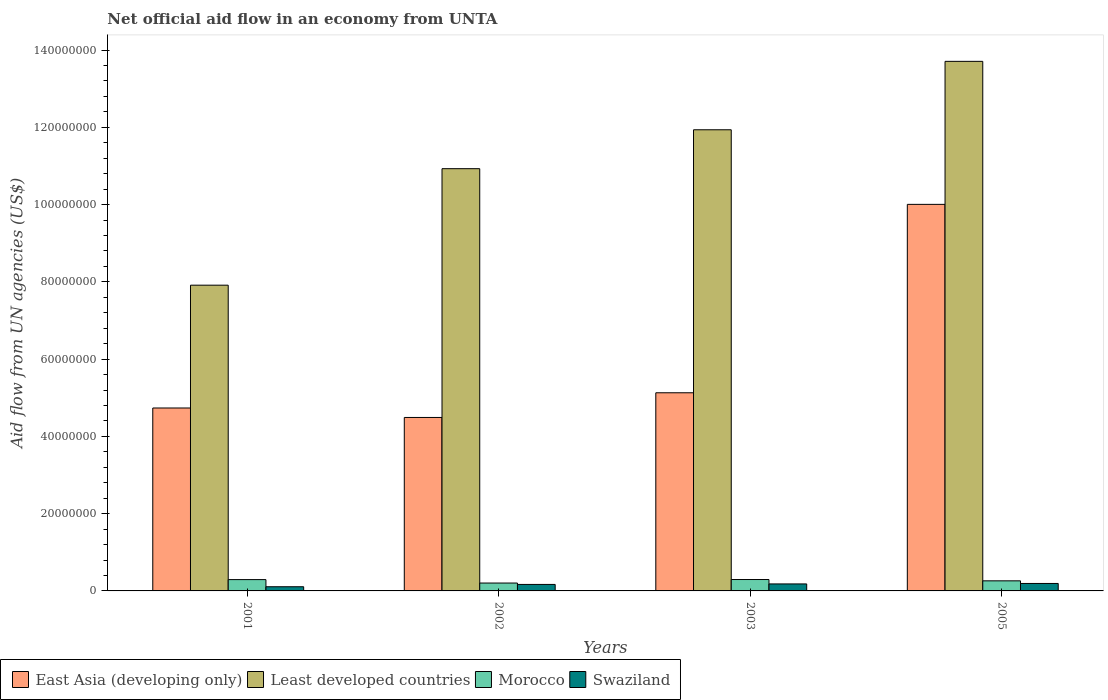How many different coloured bars are there?
Keep it short and to the point. 4. Are the number of bars per tick equal to the number of legend labels?
Give a very brief answer. Yes. Are the number of bars on each tick of the X-axis equal?
Your response must be concise. Yes. How many bars are there on the 1st tick from the right?
Offer a very short reply. 4. What is the label of the 3rd group of bars from the left?
Ensure brevity in your answer.  2003. What is the net official aid flow in Morocco in 2005?
Your answer should be compact. 2.61e+06. Across all years, what is the maximum net official aid flow in Least developed countries?
Offer a very short reply. 1.37e+08. Across all years, what is the minimum net official aid flow in Swaziland?
Make the answer very short. 1.08e+06. In which year was the net official aid flow in Morocco maximum?
Make the answer very short. 2003. What is the total net official aid flow in East Asia (developing only) in the graph?
Offer a very short reply. 2.44e+08. What is the difference between the net official aid flow in Morocco in 2003 and the net official aid flow in East Asia (developing only) in 2002?
Offer a very short reply. -4.20e+07. What is the average net official aid flow in East Asia (developing only) per year?
Your answer should be very brief. 6.09e+07. In the year 2001, what is the difference between the net official aid flow in Swaziland and net official aid flow in East Asia (developing only)?
Your response must be concise. -4.63e+07. In how many years, is the net official aid flow in Morocco greater than 76000000 US$?
Ensure brevity in your answer.  0. What is the ratio of the net official aid flow in Swaziland in 2001 to that in 2005?
Offer a very short reply. 0.56. Is the net official aid flow in Swaziland in 2002 less than that in 2005?
Your answer should be compact. Yes. Is the difference between the net official aid flow in Swaziland in 2003 and 2005 greater than the difference between the net official aid flow in East Asia (developing only) in 2003 and 2005?
Give a very brief answer. Yes. What is the difference between the highest and the second highest net official aid flow in East Asia (developing only)?
Make the answer very short. 4.88e+07. What is the difference between the highest and the lowest net official aid flow in Swaziland?
Keep it short and to the point. 8.50e+05. In how many years, is the net official aid flow in East Asia (developing only) greater than the average net official aid flow in East Asia (developing only) taken over all years?
Offer a very short reply. 1. Is the sum of the net official aid flow in Swaziland in 2001 and 2002 greater than the maximum net official aid flow in East Asia (developing only) across all years?
Give a very brief answer. No. Is it the case that in every year, the sum of the net official aid flow in Least developed countries and net official aid flow in Morocco is greater than the sum of net official aid flow in Swaziland and net official aid flow in East Asia (developing only)?
Provide a succinct answer. No. What does the 4th bar from the left in 2003 represents?
Provide a succinct answer. Swaziland. What does the 1st bar from the right in 2003 represents?
Provide a succinct answer. Swaziland. Is it the case that in every year, the sum of the net official aid flow in East Asia (developing only) and net official aid flow in Least developed countries is greater than the net official aid flow in Swaziland?
Keep it short and to the point. Yes. How many years are there in the graph?
Give a very brief answer. 4. What is the title of the graph?
Your answer should be very brief. Net official aid flow in an economy from UNTA. What is the label or title of the X-axis?
Offer a very short reply. Years. What is the label or title of the Y-axis?
Ensure brevity in your answer.  Aid flow from UN agencies (US$). What is the Aid flow from UN agencies (US$) in East Asia (developing only) in 2001?
Your answer should be very brief. 4.74e+07. What is the Aid flow from UN agencies (US$) in Least developed countries in 2001?
Ensure brevity in your answer.  7.91e+07. What is the Aid flow from UN agencies (US$) in Morocco in 2001?
Give a very brief answer. 2.93e+06. What is the Aid flow from UN agencies (US$) in Swaziland in 2001?
Your answer should be compact. 1.08e+06. What is the Aid flow from UN agencies (US$) of East Asia (developing only) in 2002?
Make the answer very short. 4.49e+07. What is the Aid flow from UN agencies (US$) of Least developed countries in 2002?
Your response must be concise. 1.09e+08. What is the Aid flow from UN agencies (US$) of Morocco in 2002?
Provide a short and direct response. 2.04e+06. What is the Aid flow from UN agencies (US$) in Swaziland in 2002?
Keep it short and to the point. 1.68e+06. What is the Aid flow from UN agencies (US$) in East Asia (developing only) in 2003?
Give a very brief answer. 5.13e+07. What is the Aid flow from UN agencies (US$) in Least developed countries in 2003?
Ensure brevity in your answer.  1.19e+08. What is the Aid flow from UN agencies (US$) of Morocco in 2003?
Your answer should be very brief. 2.95e+06. What is the Aid flow from UN agencies (US$) in Swaziland in 2003?
Your answer should be compact. 1.81e+06. What is the Aid flow from UN agencies (US$) in East Asia (developing only) in 2005?
Make the answer very short. 1.00e+08. What is the Aid flow from UN agencies (US$) of Least developed countries in 2005?
Provide a short and direct response. 1.37e+08. What is the Aid flow from UN agencies (US$) of Morocco in 2005?
Provide a short and direct response. 2.61e+06. What is the Aid flow from UN agencies (US$) in Swaziland in 2005?
Make the answer very short. 1.93e+06. Across all years, what is the maximum Aid flow from UN agencies (US$) in East Asia (developing only)?
Provide a succinct answer. 1.00e+08. Across all years, what is the maximum Aid flow from UN agencies (US$) of Least developed countries?
Make the answer very short. 1.37e+08. Across all years, what is the maximum Aid flow from UN agencies (US$) of Morocco?
Your answer should be compact. 2.95e+06. Across all years, what is the maximum Aid flow from UN agencies (US$) in Swaziland?
Your response must be concise. 1.93e+06. Across all years, what is the minimum Aid flow from UN agencies (US$) of East Asia (developing only)?
Make the answer very short. 4.49e+07. Across all years, what is the minimum Aid flow from UN agencies (US$) of Least developed countries?
Give a very brief answer. 7.91e+07. Across all years, what is the minimum Aid flow from UN agencies (US$) of Morocco?
Your response must be concise. 2.04e+06. Across all years, what is the minimum Aid flow from UN agencies (US$) of Swaziland?
Your response must be concise. 1.08e+06. What is the total Aid flow from UN agencies (US$) of East Asia (developing only) in the graph?
Your answer should be very brief. 2.44e+08. What is the total Aid flow from UN agencies (US$) in Least developed countries in the graph?
Offer a terse response. 4.45e+08. What is the total Aid flow from UN agencies (US$) of Morocco in the graph?
Provide a short and direct response. 1.05e+07. What is the total Aid flow from UN agencies (US$) in Swaziland in the graph?
Offer a terse response. 6.50e+06. What is the difference between the Aid flow from UN agencies (US$) of East Asia (developing only) in 2001 and that in 2002?
Provide a short and direct response. 2.45e+06. What is the difference between the Aid flow from UN agencies (US$) in Least developed countries in 2001 and that in 2002?
Ensure brevity in your answer.  -3.02e+07. What is the difference between the Aid flow from UN agencies (US$) of Morocco in 2001 and that in 2002?
Provide a short and direct response. 8.90e+05. What is the difference between the Aid flow from UN agencies (US$) in Swaziland in 2001 and that in 2002?
Your answer should be compact. -6.00e+05. What is the difference between the Aid flow from UN agencies (US$) of East Asia (developing only) in 2001 and that in 2003?
Offer a terse response. -3.94e+06. What is the difference between the Aid flow from UN agencies (US$) of Least developed countries in 2001 and that in 2003?
Offer a terse response. -4.02e+07. What is the difference between the Aid flow from UN agencies (US$) in Swaziland in 2001 and that in 2003?
Offer a terse response. -7.30e+05. What is the difference between the Aid flow from UN agencies (US$) of East Asia (developing only) in 2001 and that in 2005?
Your response must be concise. -5.27e+07. What is the difference between the Aid flow from UN agencies (US$) in Least developed countries in 2001 and that in 2005?
Keep it short and to the point. -5.79e+07. What is the difference between the Aid flow from UN agencies (US$) of Swaziland in 2001 and that in 2005?
Provide a short and direct response. -8.50e+05. What is the difference between the Aid flow from UN agencies (US$) in East Asia (developing only) in 2002 and that in 2003?
Keep it short and to the point. -6.39e+06. What is the difference between the Aid flow from UN agencies (US$) in Least developed countries in 2002 and that in 2003?
Keep it short and to the point. -1.01e+07. What is the difference between the Aid flow from UN agencies (US$) in Morocco in 2002 and that in 2003?
Give a very brief answer. -9.10e+05. What is the difference between the Aid flow from UN agencies (US$) in East Asia (developing only) in 2002 and that in 2005?
Provide a short and direct response. -5.52e+07. What is the difference between the Aid flow from UN agencies (US$) in Least developed countries in 2002 and that in 2005?
Make the answer very short. -2.78e+07. What is the difference between the Aid flow from UN agencies (US$) in Morocco in 2002 and that in 2005?
Your response must be concise. -5.70e+05. What is the difference between the Aid flow from UN agencies (US$) in East Asia (developing only) in 2003 and that in 2005?
Provide a short and direct response. -4.88e+07. What is the difference between the Aid flow from UN agencies (US$) of Least developed countries in 2003 and that in 2005?
Your answer should be compact. -1.77e+07. What is the difference between the Aid flow from UN agencies (US$) in East Asia (developing only) in 2001 and the Aid flow from UN agencies (US$) in Least developed countries in 2002?
Make the answer very short. -6.20e+07. What is the difference between the Aid flow from UN agencies (US$) of East Asia (developing only) in 2001 and the Aid flow from UN agencies (US$) of Morocco in 2002?
Offer a very short reply. 4.53e+07. What is the difference between the Aid flow from UN agencies (US$) in East Asia (developing only) in 2001 and the Aid flow from UN agencies (US$) in Swaziland in 2002?
Provide a short and direct response. 4.57e+07. What is the difference between the Aid flow from UN agencies (US$) in Least developed countries in 2001 and the Aid flow from UN agencies (US$) in Morocco in 2002?
Offer a terse response. 7.71e+07. What is the difference between the Aid flow from UN agencies (US$) in Least developed countries in 2001 and the Aid flow from UN agencies (US$) in Swaziland in 2002?
Offer a terse response. 7.75e+07. What is the difference between the Aid flow from UN agencies (US$) in Morocco in 2001 and the Aid flow from UN agencies (US$) in Swaziland in 2002?
Your answer should be very brief. 1.25e+06. What is the difference between the Aid flow from UN agencies (US$) in East Asia (developing only) in 2001 and the Aid flow from UN agencies (US$) in Least developed countries in 2003?
Ensure brevity in your answer.  -7.20e+07. What is the difference between the Aid flow from UN agencies (US$) of East Asia (developing only) in 2001 and the Aid flow from UN agencies (US$) of Morocco in 2003?
Give a very brief answer. 4.44e+07. What is the difference between the Aid flow from UN agencies (US$) of East Asia (developing only) in 2001 and the Aid flow from UN agencies (US$) of Swaziland in 2003?
Your answer should be compact. 4.55e+07. What is the difference between the Aid flow from UN agencies (US$) of Least developed countries in 2001 and the Aid flow from UN agencies (US$) of Morocco in 2003?
Give a very brief answer. 7.62e+07. What is the difference between the Aid flow from UN agencies (US$) of Least developed countries in 2001 and the Aid flow from UN agencies (US$) of Swaziland in 2003?
Ensure brevity in your answer.  7.73e+07. What is the difference between the Aid flow from UN agencies (US$) of Morocco in 2001 and the Aid flow from UN agencies (US$) of Swaziland in 2003?
Provide a succinct answer. 1.12e+06. What is the difference between the Aid flow from UN agencies (US$) in East Asia (developing only) in 2001 and the Aid flow from UN agencies (US$) in Least developed countries in 2005?
Make the answer very short. -8.97e+07. What is the difference between the Aid flow from UN agencies (US$) of East Asia (developing only) in 2001 and the Aid flow from UN agencies (US$) of Morocco in 2005?
Ensure brevity in your answer.  4.47e+07. What is the difference between the Aid flow from UN agencies (US$) in East Asia (developing only) in 2001 and the Aid flow from UN agencies (US$) in Swaziland in 2005?
Provide a succinct answer. 4.54e+07. What is the difference between the Aid flow from UN agencies (US$) in Least developed countries in 2001 and the Aid flow from UN agencies (US$) in Morocco in 2005?
Keep it short and to the point. 7.65e+07. What is the difference between the Aid flow from UN agencies (US$) in Least developed countries in 2001 and the Aid flow from UN agencies (US$) in Swaziland in 2005?
Make the answer very short. 7.72e+07. What is the difference between the Aid flow from UN agencies (US$) of Morocco in 2001 and the Aid flow from UN agencies (US$) of Swaziland in 2005?
Your answer should be very brief. 1.00e+06. What is the difference between the Aid flow from UN agencies (US$) of East Asia (developing only) in 2002 and the Aid flow from UN agencies (US$) of Least developed countries in 2003?
Offer a very short reply. -7.45e+07. What is the difference between the Aid flow from UN agencies (US$) in East Asia (developing only) in 2002 and the Aid flow from UN agencies (US$) in Morocco in 2003?
Offer a very short reply. 4.20e+07. What is the difference between the Aid flow from UN agencies (US$) of East Asia (developing only) in 2002 and the Aid flow from UN agencies (US$) of Swaziland in 2003?
Your response must be concise. 4.31e+07. What is the difference between the Aid flow from UN agencies (US$) in Least developed countries in 2002 and the Aid flow from UN agencies (US$) in Morocco in 2003?
Ensure brevity in your answer.  1.06e+08. What is the difference between the Aid flow from UN agencies (US$) in Least developed countries in 2002 and the Aid flow from UN agencies (US$) in Swaziland in 2003?
Ensure brevity in your answer.  1.07e+08. What is the difference between the Aid flow from UN agencies (US$) in Morocco in 2002 and the Aid flow from UN agencies (US$) in Swaziland in 2003?
Your response must be concise. 2.30e+05. What is the difference between the Aid flow from UN agencies (US$) of East Asia (developing only) in 2002 and the Aid flow from UN agencies (US$) of Least developed countries in 2005?
Your answer should be very brief. -9.22e+07. What is the difference between the Aid flow from UN agencies (US$) of East Asia (developing only) in 2002 and the Aid flow from UN agencies (US$) of Morocco in 2005?
Give a very brief answer. 4.23e+07. What is the difference between the Aid flow from UN agencies (US$) in East Asia (developing only) in 2002 and the Aid flow from UN agencies (US$) in Swaziland in 2005?
Your answer should be compact. 4.30e+07. What is the difference between the Aid flow from UN agencies (US$) in Least developed countries in 2002 and the Aid flow from UN agencies (US$) in Morocco in 2005?
Offer a very short reply. 1.07e+08. What is the difference between the Aid flow from UN agencies (US$) of Least developed countries in 2002 and the Aid flow from UN agencies (US$) of Swaziland in 2005?
Provide a succinct answer. 1.07e+08. What is the difference between the Aid flow from UN agencies (US$) in East Asia (developing only) in 2003 and the Aid flow from UN agencies (US$) in Least developed countries in 2005?
Your answer should be very brief. -8.58e+07. What is the difference between the Aid flow from UN agencies (US$) of East Asia (developing only) in 2003 and the Aid flow from UN agencies (US$) of Morocco in 2005?
Provide a short and direct response. 4.87e+07. What is the difference between the Aid flow from UN agencies (US$) in East Asia (developing only) in 2003 and the Aid flow from UN agencies (US$) in Swaziland in 2005?
Offer a very short reply. 4.94e+07. What is the difference between the Aid flow from UN agencies (US$) of Least developed countries in 2003 and the Aid flow from UN agencies (US$) of Morocco in 2005?
Keep it short and to the point. 1.17e+08. What is the difference between the Aid flow from UN agencies (US$) of Least developed countries in 2003 and the Aid flow from UN agencies (US$) of Swaziland in 2005?
Your response must be concise. 1.17e+08. What is the difference between the Aid flow from UN agencies (US$) in Morocco in 2003 and the Aid flow from UN agencies (US$) in Swaziland in 2005?
Your answer should be compact. 1.02e+06. What is the average Aid flow from UN agencies (US$) of East Asia (developing only) per year?
Your response must be concise. 6.09e+07. What is the average Aid flow from UN agencies (US$) of Least developed countries per year?
Offer a very short reply. 1.11e+08. What is the average Aid flow from UN agencies (US$) in Morocco per year?
Provide a short and direct response. 2.63e+06. What is the average Aid flow from UN agencies (US$) of Swaziland per year?
Ensure brevity in your answer.  1.62e+06. In the year 2001, what is the difference between the Aid flow from UN agencies (US$) in East Asia (developing only) and Aid flow from UN agencies (US$) in Least developed countries?
Ensure brevity in your answer.  -3.18e+07. In the year 2001, what is the difference between the Aid flow from UN agencies (US$) of East Asia (developing only) and Aid flow from UN agencies (US$) of Morocco?
Keep it short and to the point. 4.44e+07. In the year 2001, what is the difference between the Aid flow from UN agencies (US$) of East Asia (developing only) and Aid flow from UN agencies (US$) of Swaziland?
Keep it short and to the point. 4.63e+07. In the year 2001, what is the difference between the Aid flow from UN agencies (US$) of Least developed countries and Aid flow from UN agencies (US$) of Morocco?
Make the answer very short. 7.62e+07. In the year 2001, what is the difference between the Aid flow from UN agencies (US$) of Least developed countries and Aid flow from UN agencies (US$) of Swaziland?
Provide a short and direct response. 7.81e+07. In the year 2001, what is the difference between the Aid flow from UN agencies (US$) of Morocco and Aid flow from UN agencies (US$) of Swaziland?
Your answer should be very brief. 1.85e+06. In the year 2002, what is the difference between the Aid flow from UN agencies (US$) in East Asia (developing only) and Aid flow from UN agencies (US$) in Least developed countries?
Give a very brief answer. -6.44e+07. In the year 2002, what is the difference between the Aid flow from UN agencies (US$) of East Asia (developing only) and Aid flow from UN agencies (US$) of Morocco?
Offer a very short reply. 4.29e+07. In the year 2002, what is the difference between the Aid flow from UN agencies (US$) of East Asia (developing only) and Aid flow from UN agencies (US$) of Swaziland?
Offer a terse response. 4.32e+07. In the year 2002, what is the difference between the Aid flow from UN agencies (US$) of Least developed countries and Aid flow from UN agencies (US$) of Morocco?
Offer a terse response. 1.07e+08. In the year 2002, what is the difference between the Aid flow from UN agencies (US$) of Least developed countries and Aid flow from UN agencies (US$) of Swaziland?
Give a very brief answer. 1.08e+08. In the year 2002, what is the difference between the Aid flow from UN agencies (US$) in Morocco and Aid flow from UN agencies (US$) in Swaziland?
Ensure brevity in your answer.  3.60e+05. In the year 2003, what is the difference between the Aid flow from UN agencies (US$) in East Asia (developing only) and Aid flow from UN agencies (US$) in Least developed countries?
Your response must be concise. -6.81e+07. In the year 2003, what is the difference between the Aid flow from UN agencies (US$) in East Asia (developing only) and Aid flow from UN agencies (US$) in Morocco?
Your answer should be compact. 4.83e+07. In the year 2003, what is the difference between the Aid flow from UN agencies (US$) of East Asia (developing only) and Aid flow from UN agencies (US$) of Swaziland?
Offer a terse response. 4.95e+07. In the year 2003, what is the difference between the Aid flow from UN agencies (US$) in Least developed countries and Aid flow from UN agencies (US$) in Morocco?
Provide a succinct answer. 1.16e+08. In the year 2003, what is the difference between the Aid flow from UN agencies (US$) of Least developed countries and Aid flow from UN agencies (US$) of Swaziland?
Ensure brevity in your answer.  1.18e+08. In the year 2003, what is the difference between the Aid flow from UN agencies (US$) in Morocco and Aid flow from UN agencies (US$) in Swaziland?
Offer a very short reply. 1.14e+06. In the year 2005, what is the difference between the Aid flow from UN agencies (US$) of East Asia (developing only) and Aid flow from UN agencies (US$) of Least developed countries?
Provide a short and direct response. -3.70e+07. In the year 2005, what is the difference between the Aid flow from UN agencies (US$) in East Asia (developing only) and Aid flow from UN agencies (US$) in Morocco?
Ensure brevity in your answer.  9.74e+07. In the year 2005, what is the difference between the Aid flow from UN agencies (US$) in East Asia (developing only) and Aid flow from UN agencies (US$) in Swaziland?
Offer a terse response. 9.81e+07. In the year 2005, what is the difference between the Aid flow from UN agencies (US$) in Least developed countries and Aid flow from UN agencies (US$) in Morocco?
Make the answer very short. 1.34e+08. In the year 2005, what is the difference between the Aid flow from UN agencies (US$) in Least developed countries and Aid flow from UN agencies (US$) in Swaziland?
Ensure brevity in your answer.  1.35e+08. In the year 2005, what is the difference between the Aid flow from UN agencies (US$) of Morocco and Aid flow from UN agencies (US$) of Swaziland?
Give a very brief answer. 6.80e+05. What is the ratio of the Aid flow from UN agencies (US$) in East Asia (developing only) in 2001 to that in 2002?
Provide a succinct answer. 1.05. What is the ratio of the Aid flow from UN agencies (US$) of Least developed countries in 2001 to that in 2002?
Ensure brevity in your answer.  0.72. What is the ratio of the Aid flow from UN agencies (US$) in Morocco in 2001 to that in 2002?
Your answer should be very brief. 1.44. What is the ratio of the Aid flow from UN agencies (US$) in Swaziland in 2001 to that in 2002?
Your answer should be compact. 0.64. What is the ratio of the Aid flow from UN agencies (US$) in East Asia (developing only) in 2001 to that in 2003?
Give a very brief answer. 0.92. What is the ratio of the Aid flow from UN agencies (US$) in Least developed countries in 2001 to that in 2003?
Offer a very short reply. 0.66. What is the ratio of the Aid flow from UN agencies (US$) of Morocco in 2001 to that in 2003?
Make the answer very short. 0.99. What is the ratio of the Aid flow from UN agencies (US$) in Swaziland in 2001 to that in 2003?
Your answer should be compact. 0.6. What is the ratio of the Aid flow from UN agencies (US$) in East Asia (developing only) in 2001 to that in 2005?
Your answer should be very brief. 0.47. What is the ratio of the Aid flow from UN agencies (US$) of Least developed countries in 2001 to that in 2005?
Your response must be concise. 0.58. What is the ratio of the Aid flow from UN agencies (US$) of Morocco in 2001 to that in 2005?
Your answer should be compact. 1.12. What is the ratio of the Aid flow from UN agencies (US$) of Swaziland in 2001 to that in 2005?
Your answer should be very brief. 0.56. What is the ratio of the Aid flow from UN agencies (US$) in East Asia (developing only) in 2002 to that in 2003?
Provide a short and direct response. 0.88. What is the ratio of the Aid flow from UN agencies (US$) of Least developed countries in 2002 to that in 2003?
Offer a terse response. 0.92. What is the ratio of the Aid flow from UN agencies (US$) in Morocco in 2002 to that in 2003?
Keep it short and to the point. 0.69. What is the ratio of the Aid flow from UN agencies (US$) in Swaziland in 2002 to that in 2003?
Provide a short and direct response. 0.93. What is the ratio of the Aid flow from UN agencies (US$) in East Asia (developing only) in 2002 to that in 2005?
Your answer should be compact. 0.45. What is the ratio of the Aid flow from UN agencies (US$) in Least developed countries in 2002 to that in 2005?
Make the answer very short. 0.8. What is the ratio of the Aid flow from UN agencies (US$) in Morocco in 2002 to that in 2005?
Offer a terse response. 0.78. What is the ratio of the Aid flow from UN agencies (US$) of Swaziland in 2002 to that in 2005?
Your answer should be very brief. 0.87. What is the ratio of the Aid flow from UN agencies (US$) in East Asia (developing only) in 2003 to that in 2005?
Provide a short and direct response. 0.51. What is the ratio of the Aid flow from UN agencies (US$) of Least developed countries in 2003 to that in 2005?
Offer a terse response. 0.87. What is the ratio of the Aid flow from UN agencies (US$) of Morocco in 2003 to that in 2005?
Your response must be concise. 1.13. What is the ratio of the Aid flow from UN agencies (US$) of Swaziland in 2003 to that in 2005?
Provide a short and direct response. 0.94. What is the difference between the highest and the second highest Aid flow from UN agencies (US$) in East Asia (developing only)?
Provide a short and direct response. 4.88e+07. What is the difference between the highest and the second highest Aid flow from UN agencies (US$) in Least developed countries?
Give a very brief answer. 1.77e+07. What is the difference between the highest and the second highest Aid flow from UN agencies (US$) of Morocco?
Make the answer very short. 2.00e+04. What is the difference between the highest and the second highest Aid flow from UN agencies (US$) in Swaziland?
Your answer should be very brief. 1.20e+05. What is the difference between the highest and the lowest Aid flow from UN agencies (US$) of East Asia (developing only)?
Your answer should be compact. 5.52e+07. What is the difference between the highest and the lowest Aid flow from UN agencies (US$) of Least developed countries?
Provide a succinct answer. 5.79e+07. What is the difference between the highest and the lowest Aid flow from UN agencies (US$) in Morocco?
Give a very brief answer. 9.10e+05. What is the difference between the highest and the lowest Aid flow from UN agencies (US$) of Swaziland?
Your answer should be compact. 8.50e+05. 